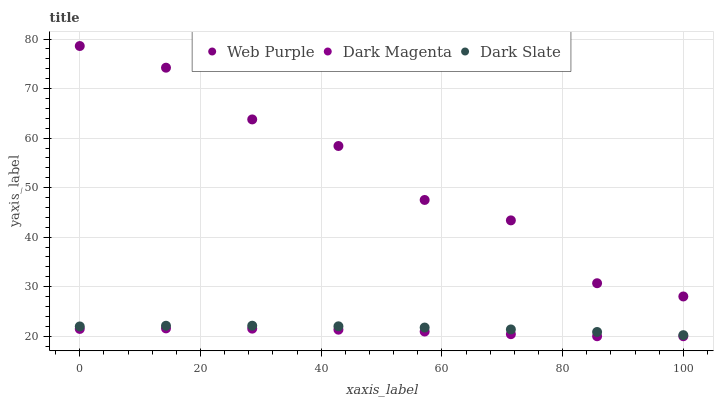Does Dark Magenta have the minimum area under the curve?
Answer yes or no. Yes. Does Web Purple have the maximum area under the curve?
Answer yes or no. Yes. Does Web Purple have the minimum area under the curve?
Answer yes or no. No. Does Dark Magenta have the maximum area under the curve?
Answer yes or no. No. Is Dark Slate the smoothest?
Answer yes or no. Yes. Is Web Purple the roughest?
Answer yes or no. Yes. Is Dark Magenta the smoothest?
Answer yes or no. No. Is Dark Magenta the roughest?
Answer yes or no. No. Does Dark Magenta have the lowest value?
Answer yes or no. Yes. Does Web Purple have the lowest value?
Answer yes or no. No. Does Web Purple have the highest value?
Answer yes or no. Yes. Does Dark Magenta have the highest value?
Answer yes or no. No. Is Dark Magenta less than Dark Slate?
Answer yes or no. Yes. Is Dark Slate greater than Dark Magenta?
Answer yes or no. Yes. Does Dark Magenta intersect Dark Slate?
Answer yes or no. No. 